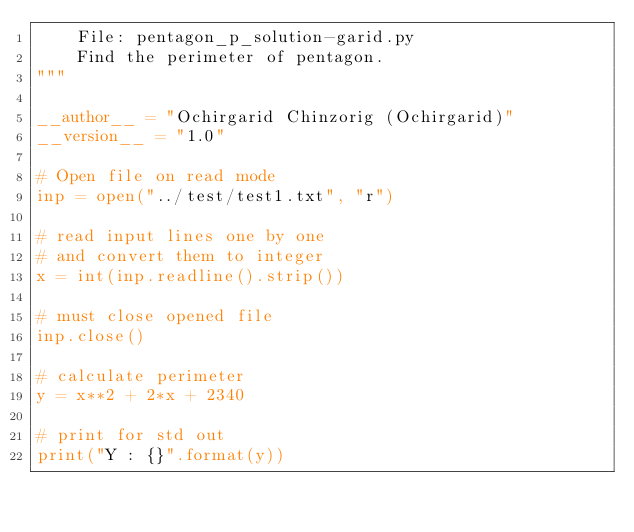Convert code to text. <code><loc_0><loc_0><loc_500><loc_500><_Python_>    File: pentagon_p_solution-garid.py
    Find the perimeter of pentagon.
"""

__author__ = "Ochirgarid Chinzorig (Ochirgarid)"
__version__ = "1.0"

# Open file on read mode
inp = open("../test/test1.txt", "r")

# read input lines one by one
# and convert them to integer
x = int(inp.readline().strip())

# must close opened file
inp.close()

# calculate perimeter
y = x**2 + 2*x + 2340

# print for std out
print("Y : {}".format(y))
</code> 